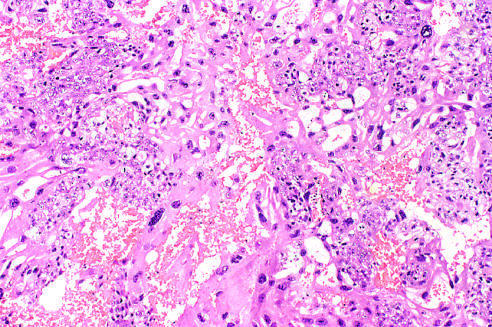does this field contain both neoplastic cytotro-phoblast and multinucleate syncytiotrophoblast?
Answer the question using a single word or phrase. Yes 